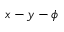Convert formula to latex. <formula><loc_0><loc_0><loc_500><loc_500>x - y - \phi</formula> 